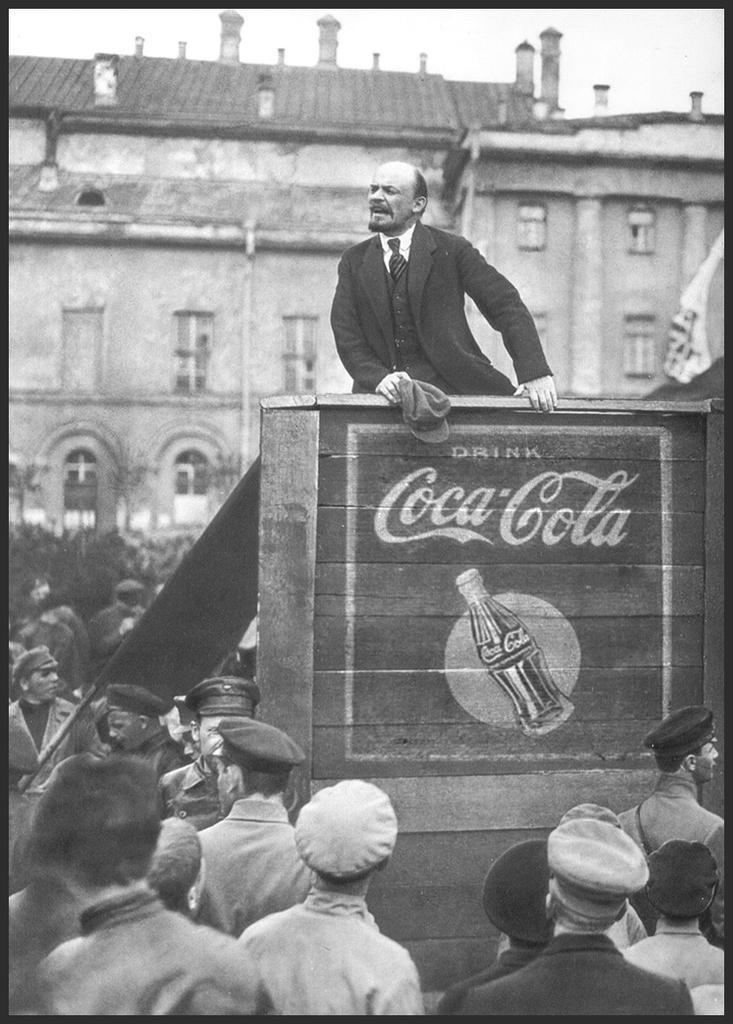In one or two sentences, can you explain what this image depicts? This is a black and white image. In the middle of the image I can see a man wearing a suit, standing by holding a wooden surface. At the bottom, I can see a crowd of people. In the background there is a building. 